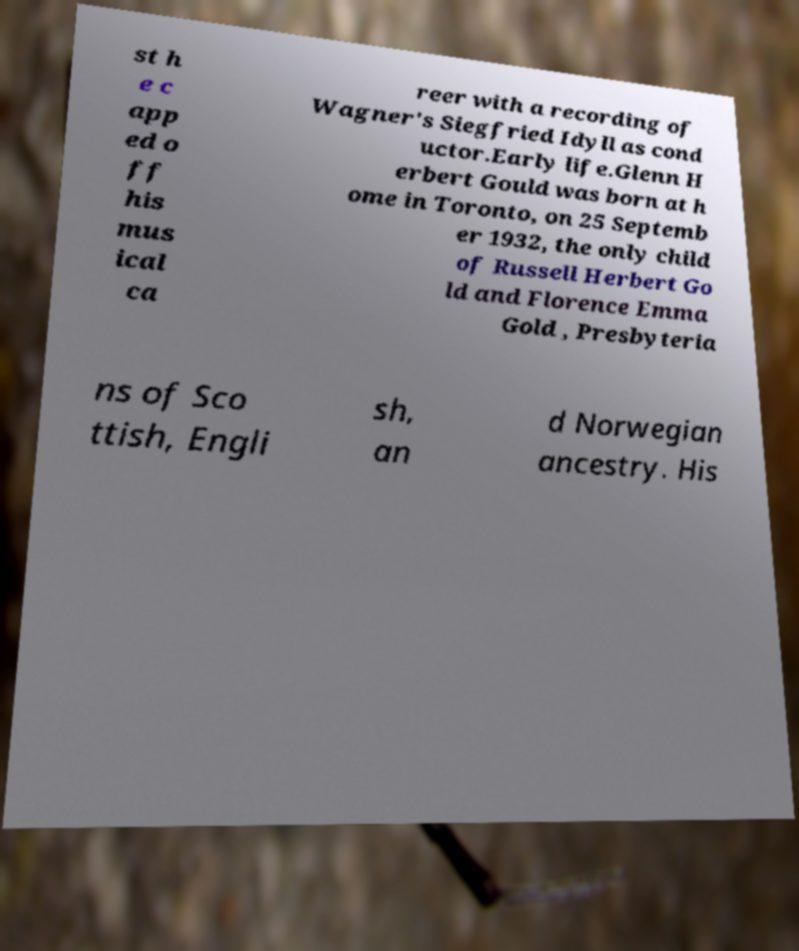For documentation purposes, I need the text within this image transcribed. Could you provide that? st h e c app ed o ff his mus ical ca reer with a recording of Wagner's Siegfried Idyll as cond uctor.Early life.Glenn H erbert Gould was born at h ome in Toronto, on 25 Septemb er 1932, the only child of Russell Herbert Go ld and Florence Emma Gold , Presbyteria ns of Sco ttish, Engli sh, an d Norwegian ancestry. His 